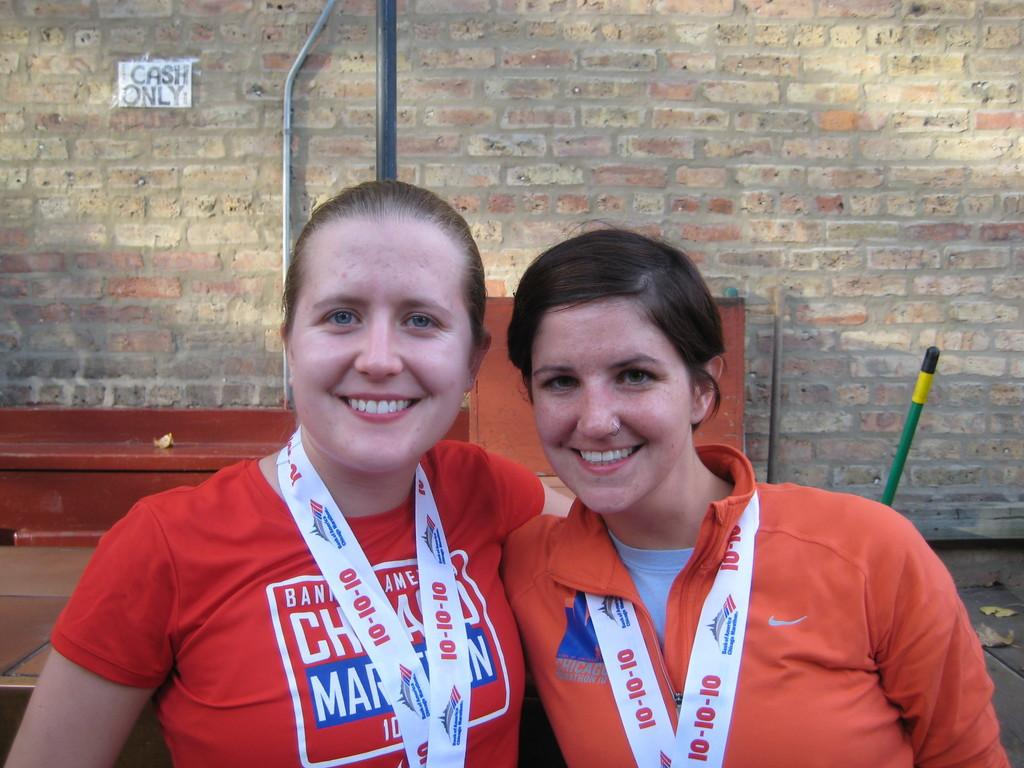<image>
Present a compact description of the photo's key features. Two ladies smiling and wearing medals around their necks with cash only in the background. 